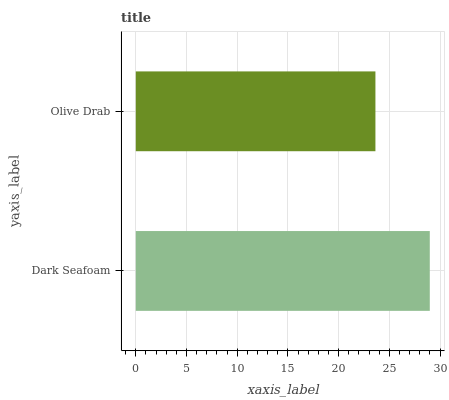Is Olive Drab the minimum?
Answer yes or no. Yes. Is Dark Seafoam the maximum?
Answer yes or no. Yes. Is Olive Drab the maximum?
Answer yes or no. No. Is Dark Seafoam greater than Olive Drab?
Answer yes or no. Yes. Is Olive Drab less than Dark Seafoam?
Answer yes or no. Yes. Is Olive Drab greater than Dark Seafoam?
Answer yes or no. No. Is Dark Seafoam less than Olive Drab?
Answer yes or no. No. Is Dark Seafoam the high median?
Answer yes or no. Yes. Is Olive Drab the low median?
Answer yes or no. Yes. Is Olive Drab the high median?
Answer yes or no. No. Is Dark Seafoam the low median?
Answer yes or no. No. 